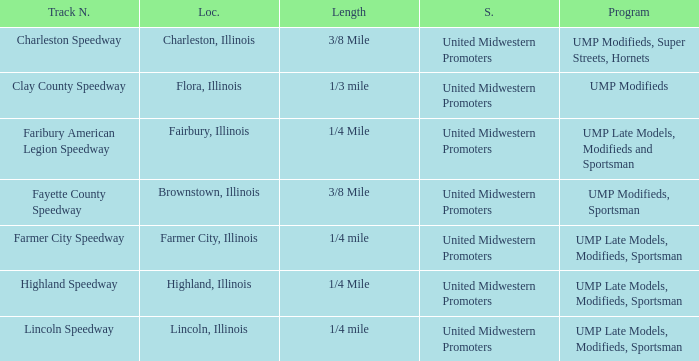What location is farmer city speedway? Farmer City, Illinois. 